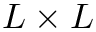<formula> <loc_0><loc_0><loc_500><loc_500>L \times L</formula> 